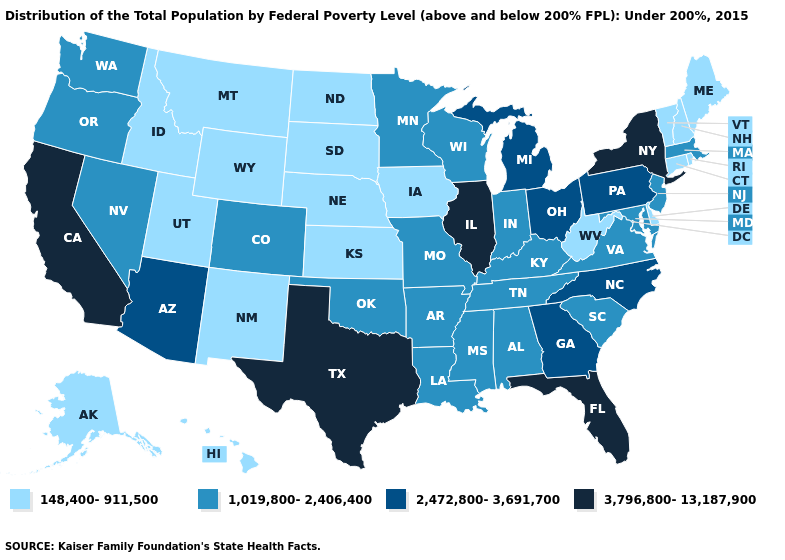Which states have the lowest value in the South?
Be succinct. Delaware, West Virginia. What is the value of North Carolina?
Be succinct. 2,472,800-3,691,700. Name the states that have a value in the range 3,796,800-13,187,900?
Answer briefly. California, Florida, Illinois, New York, Texas. Among the states that border New York , does New Jersey have the highest value?
Short answer required. No. What is the highest value in states that border New Hampshire?
Keep it brief. 1,019,800-2,406,400. Does South Carolina have a higher value than Nebraska?
Give a very brief answer. Yes. What is the value of Tennessee?
Concise answer only. 1,019,800-2,406,400. How many symbols are there in the legend?
Answer briefly. 4. How many symbols are there in the legend?
Write a very short answer. 4. Which states hav the highest value in the West?
Write a very short answer. California. Does Wisconsin have a higher value than Arizona?
Keep it brief. No. Name the states that have a value in the range 148,400-911,500?
Quick response, please. Alaska, Connecticut, Delaware, Hawaii, Idaho, Iowa, Kansas, Maine, Montana, Nebraska, New Hampshire, New Mexico, North Dakota, Rhode Island, South Dakota, Utah, Vermont, West Virginia, Wyoming. Among the states that border Louisiana , which have the highest value?
Short answer required. Texas. Name the states that have a value in the range 1,019,800-2,406,400?
Quick response, please. Alabama, Arkansas, Colorado, Indiana, Kentucky, Louisiana, Maryland, Massachusetts, Minnesota, Mississippi, Missouri, Nevada, New Jersey, Oklahoma, Oregon, South Carolina, Tennessee, Virginia, Washington, Wisconsin. 